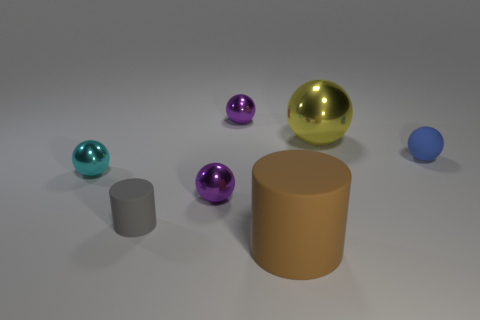Subtract all tiny matte spheres. How many spheres are left? 4 Subtract all brown cylinders. How many purple balls are left? 2 Add 1 purple balls. How many objects exist? 8 Subtract all blue balls. How many balls are left? 4 Subtract 2 balls. How many balls are left? 3 Subtract all cylinders. How many objects are left? 5 Subtract all blue cylinders. Subtract all yellow blocks. How many cylinders are left? 2 Subtract all tiny cyan metallic spheres. Subtract all yellow metal things. How many objects are left? 5 Add 5 blue rubber objects. How many blue rubber objects are left? 6 Add 2 cyan balls. How many cyan balls exist? 3 